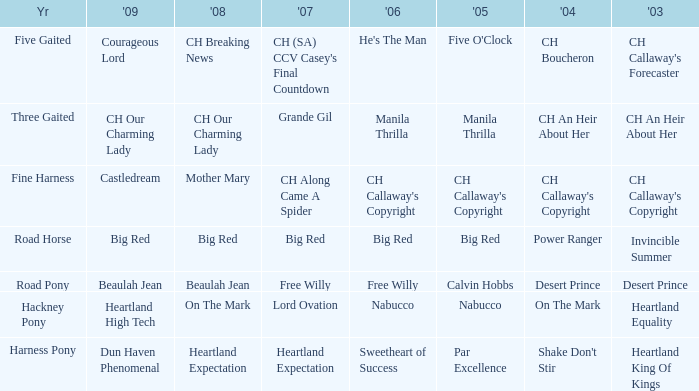What year is the 2004 shake don't stir? Harness Pony. Could you parse the entire table? {'header': ['Yr', "'09", "'08", "'07", "'06", "'05", "'04", "'03"], 'rows': [['Five Gaited', 'Courageous Lord', 'CH Breaking News', "CH (SA) CCV Casey's Final Countdown", "He's The Man", "Five O'Clock", 'CH Boucheron', "CH Callaway's Forecaster"], ['Three Gaited', 'CH Our Charming Lady', 'CH Our Charming Lady', 'Grande Gil', 'Manila Thrilla', 'Manila Thrilla', 'CH An Heir About Her', 'CH An Heir About Her'], ['Fine Harness', 'Castledream', 'Mother Mary', 'CH Along Came A Spider', "CH Callaway's Copyright", "CH Callaway's Copyright", "CH Callaway's Copyright", "CH Callaway's Copyright"], ['Road Horse', 'Big Red', 'Big Red', 'Big Red', 'Big Red', 'Big Red', 'Power Ranger', 'Invincible Summer'], ['Road Pony', 'Beaulah Jean', 'Beaulah Jean', 'Free Willy', 'Free Willy', 'Calvin Hobbs', 'Desert Prince', 'Desert Prince'], ['Hackney Pony', 'Heartland High Tech', 'On The Mark', 'Lord Ovation', 'Nabucco', 'Nabucco', 'On The Mark', 'Heartland Equality'], ['Harness Pony', 'Dun Haven Phenomenal', 'Heartland Expectation', 'Heartland Expectation', 'Sweetheart of Success', 'Par Excellence', "Shake Don't Stir", 'Heartland King Of Kings']]} 